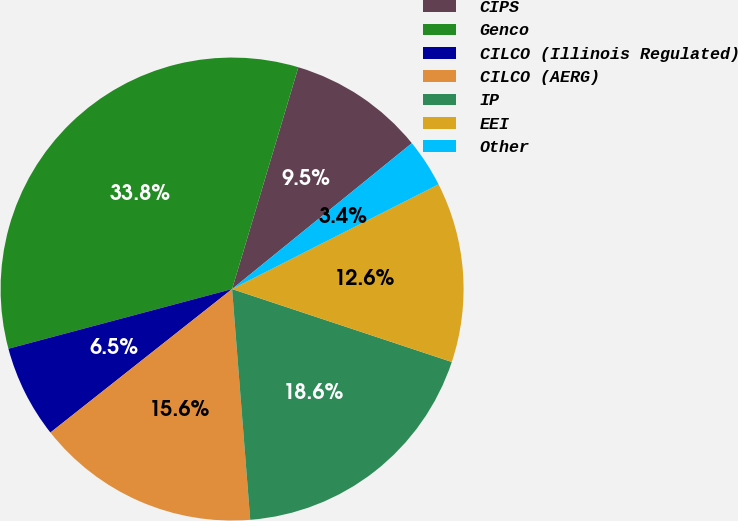Convert chart. <chart><loc_0><loc_0><loc_500><loc_500><pie_chart><fcel>CIPS<fcel>Genco<fcel>CILCO (Illinois Regulated)<fcel>CILCO (AERG)<fcel>IP<fcel>EEI<fcel>Other<nl><fcel>9.53%<fcel>33.77%<fcel>6.49%<fcel>15.61%<fcel>18.65%<fcel>12.57%<fcel>3.38%<nl></chart> 